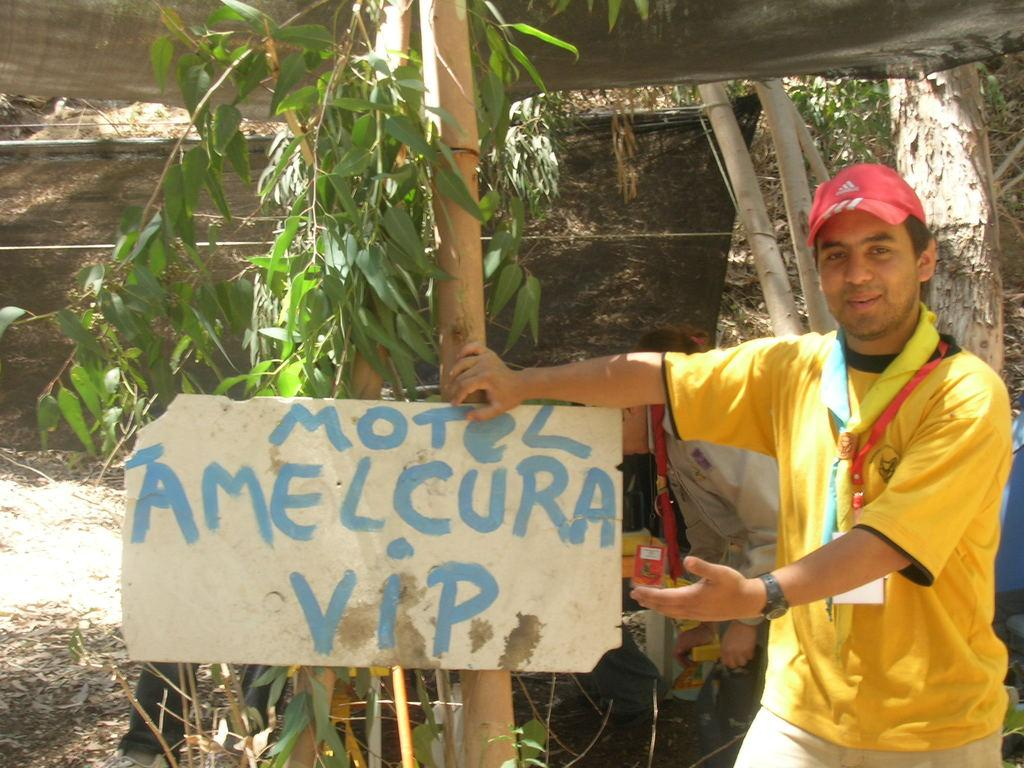What is the main subject in the image? There is a man standing in the image. What is attached to the tree in the image? There is a board on a tree in the image. What can be seen in the distance in the image? There are people and trees visible in the background of the image, as well as a tent. What type of flowers can be seen growing around the man's throat in the image? There are no flowers visible in the image, nor are there any flowers growing around the man's throat. 